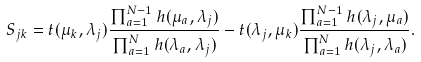Convert formula to latex. <formula><loc_0><loc_0><loc_500><loc_500>S _ { j k } = t ( \mu _ { k } , \lambda _ { j } ) \frac { \prod _ { a = 1 } ^ { N - 1 } h ( \mu _ { a } , \lambda _ { j } ) } { \prod _ { a = 1 } ^ { N } h ( \lambda _ { a } , \lambda _ { j } ) } - t ( \lambda _ { j } , \mu _ { k } ) \frac { \prod _ { a = 1 } ^ { N - 1 } h ( \lambda _ { j } , \mu _ { a } ) } { \prod _ { a = 1 } ^ { N } h ( \lambda _ { j } , \lambda _ { a } ) } .</formula> 